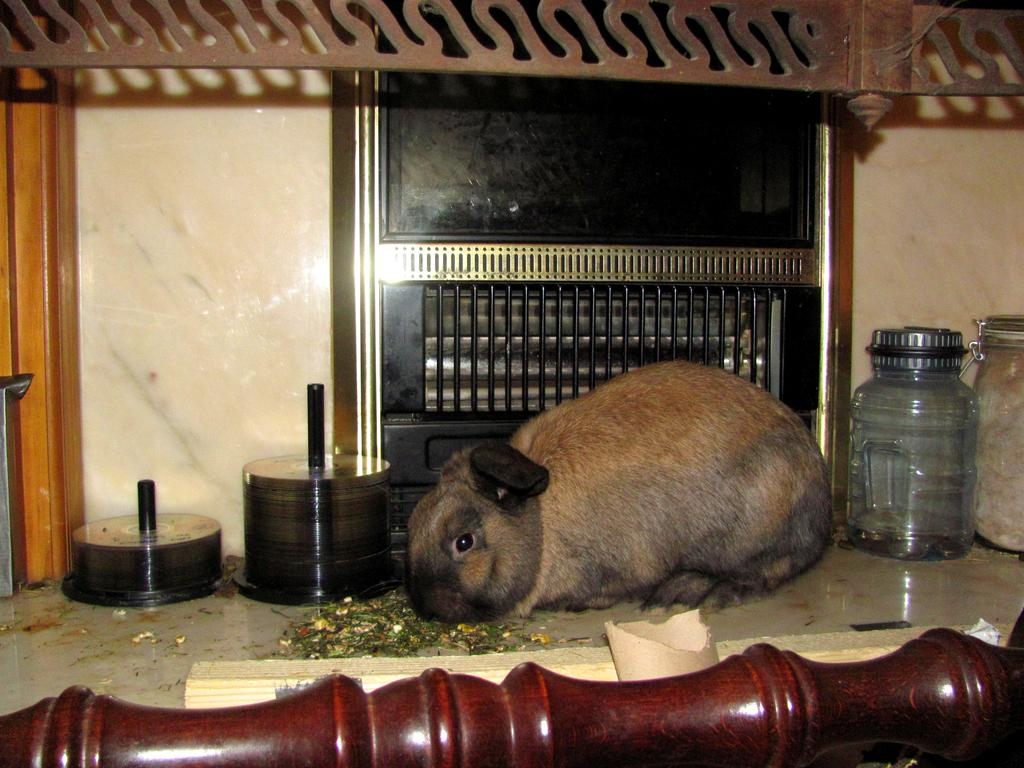What type of animal is in the image? There is an animal in the image, but its specific type cannot be determined from the provided facts. Can you describe the color of the animal? The animal is pale brown and black in color. What other objects can be seen in the image? There are glass jars, a compact disc, a fence, and wooden furniture in the image. What type of fuel is being used by the baby in the image? There is no baby present in the image, and therefore no fuel usage can be observed. Is the image taken during the winter season? The provided facts do not mention any details about the season or weather, so it cannot be determined if the image was taken during winter. 